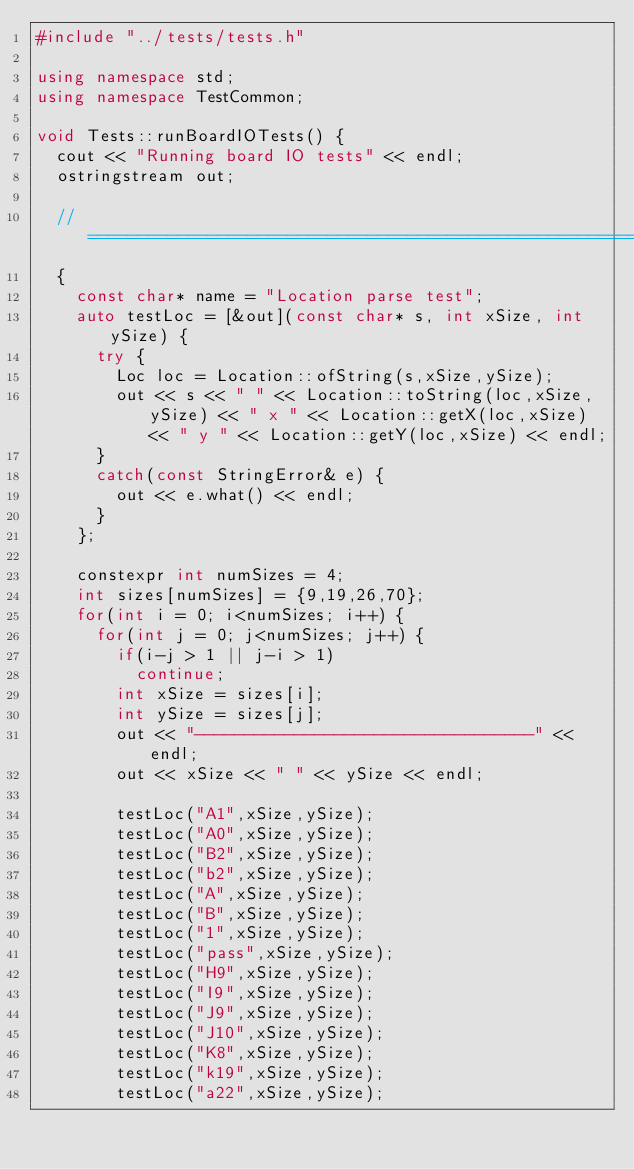Convert code to text. <code><loc_0><loc_0><loc_500><loc_500><_C++_>#include "../tests/tests.h"

using namespace std;
using namespace TestCommon;

void Tests::runBoardIOTests() {
  cout << "Running board IO tests" << endl;
  ostringstream out;

  //============================================================================
  {
    const char* name = "Location parse test";
    auto testLoc = [&out](const char* s, int xSize, int ySize) {
      try {
        Loc loc = Location::ofString(s,xSize,ySize);
        out << s << " " << Location::toString(loc,xSize,ySize) << " x " << Location::getX(loc,xSize) << " y " << Location::getY(loc,xSize) << endl;
      }
      catch(const StringError& e) {
        out << e.what() << endl;
      }
    };

    constexpr int numSizes = 4;
    int sizes[numSizes] = {9,19,26,70};
    for(int i = 0; i<numSizes; i++) {
      for(int j = 0; j<numSizes; j++) {
        if(i-j > 1 || j-i > 1)
          continue;
        int xSize = sizes[i];
        int ySize = sizes[j];
        out << "----------------------------------" << endl;
        out << xSize << " " << ySize << endl;

        testLoc("A1",xSize,ySize);
        testLoc("A0",xSize,ySize);
        testLoc("B2",xSize,ySize);
        testLoc("b2",xSize,ySize);
        testLoc("A",xSize,ySize);
        testLoc("B",xSize,ySize);
        testLoc("1",xSize,ySize);
        testLoc("pass",xSize,ySize);
        testLoc("H9",xSize,ySize);
        testLoc("I9",xSize,ySize);
        testLoc("J9",xSize,ySize);
        testLoc("J10",xSize,ySize);
        testLoc("K8",xSize,ySize);
        testLoc("k19",xSize,ySize);
        testLoc("a22",xSize,ySize);</code> 